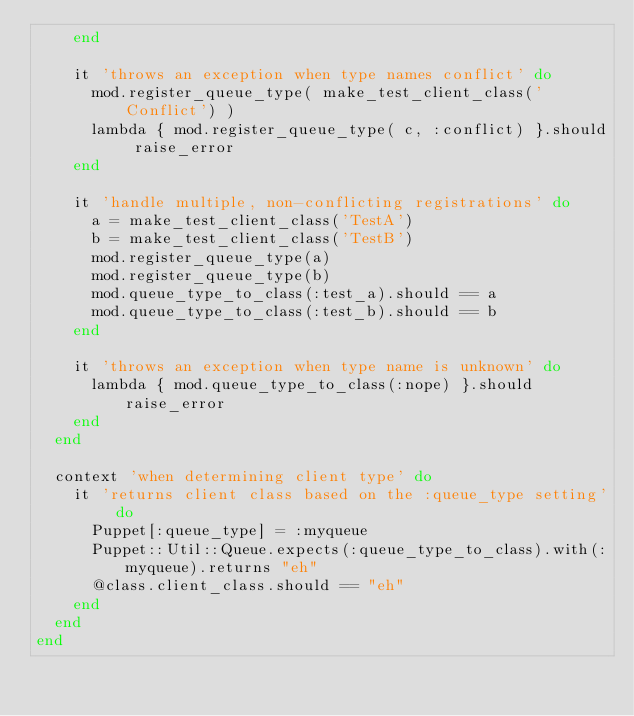<code> <loc_0><loc_0><loc_500><loc_500><_Ruby_>    end

    it 'throws an exception when type names conflict' do
      mod.register_queue_type( make_test_client_class('Conflict') )
      lambda { mod.register_queue_type( c, :conflict) }.should raise_error
    end

    it 'handle multiple, non-conflicting registrations' do
      a = make_test_client_class('TestA')
      b = make_test_client_class('TestB')
      mod.register_queue_type(a)
      mod.register_queue_type(b)
      mod.queue_type_to_class(:test_a).should == a
      mod.queue_type_to_class(:test_b).should == b
    end

    it 'throws an exception when type name is unknown' do
      lambda { mod.queue_type_to_class(:nope) }.should raise_error
    end
  end

  context 'when determining client type' do
    it 'returns client class based on the :queue_type setting' do
      Puppet[:queue_type] = :myqueue
      Puppet::Util::Queue.expects(:queue_type_to_class).with(:myqueue).returns "eh"
      @class.client_class.should == "eh"
    end
  end
end
</code> 